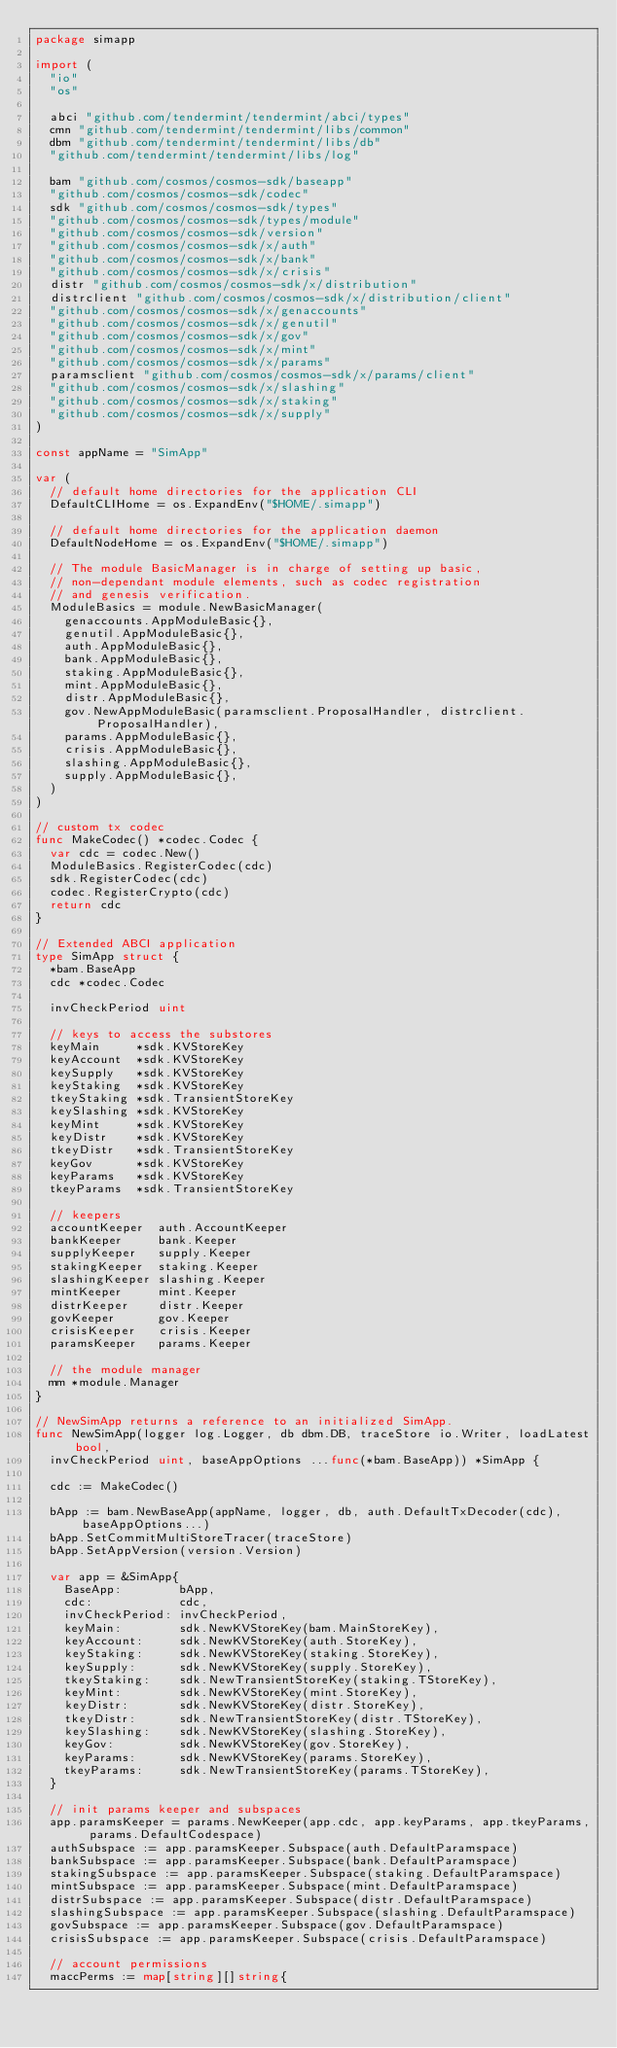<code> <loc_0><loc_0><loc_500><loc_500><_Go_>package simapp

import (
	"io"
	"os"

	abci "github.com/tendermint/tendermint/abci/types"
	cmn "github.com/tendermint/tendermint/libs/common"
	dbm "github.com/tendermint/tendermint/libs/db"
	"github.com/tendermint/tendermint/libs/log"

	bam "github.com/cosmos/cosmos-sdk/baseapp"
	"github.com/cosmos/cosmos-sdk/codec"
	sdk "github.com/cosmos/cosmos-sdk/types"
	"github.com/cosmos/cosmos-sdk/types/module"
	"github.com/cosmos/cosmos-sdk/version"
	"github.com/cosmos/cosmos-sdk/x/auth"
	"github.com/cosmos/cosmos-sdk/x/bank"
	"github.com/cosmos/cosmos-sdk/x/crisis"
	distr "github.com/cosmos/cosmos-sdk/x/distribution"
	distrclient "github.com/cosmos/cosmos-sdk/x/distribution/client"
	"github.com/cosmos/cosmos-sdk/x/genaccounts"
	"github.com/cosmos/cosmos-sdk/x/genutil"
	"github.com/cosmos/cosmos-sdk/x/gov"
	"github.com/cosmos/cosmos-sdk/x/mint"
	"github.com/cosmos/cosmos-sdk/x/params"
	paramsclient "github.com/cosmos/cosmos-sdk/x/params/client"
	"github.com/cosmos/cosmos-sdk/x/slashing"
	"github.com/cosmos/cosmos-sdk/x/staking"
	"github.com/cosmos/cosmos-sdk/x/supply"
)

const appName = "SimApp"

var (
	// default home directories for the application CLI
	DefaultCLIHome = os.ExpandEnv("$HOME/.simapp")

	// default home directories for the application daemon
	DefaultNodeHome = os.ExpandEnv("$HOME/.simapp")

	// The module BasicManager is in charge of setting up basic,
	// non-dependant module elements, such as codec registration
	// and genesis verification.
	ModuleBasics = module.NewBasicManager(
		genaccounts.AppModuleBasic{},
		genutil.AppModuleBasic{},
		auth.AppModuleBasic{},
		bank.AppModuleBasic{},
		staking.AppModuleBasic{},
		mint.AppModuleBasic{},
		distr.AppModuleBasic{},
		gov.NewAppModuleBasic(paramsclient.ProposalHandler, distrclient.ProposalHandler),
		params.AppModuleBasic{},
		crisis.AppModuleBasic{},
		slashing.AppModuleBasic{},
		supply.AppModuleBasic{},
	)
)

// custom tx codec
func MakeCodec() *codec.Codec {
	var cdc = codec.New()
	ModuleBasics.RegisterCodec(cdc)
	sdk.RegisterCodec(cdc)
	codec.RegisterCrypto(cdc)
	return cdc
}

// Extended ABCI application
type SimApp struct {
	*bam.BaseApp
	cdc *codec.Codec

	invCheckPeriod uint

	// keys to access the substores
	keyMain     *sdk.KVStoreKey
	keyAccount  *sdk.KVStoreKey
	keySupply   *sdk.KVStoreKey
	keyStaking  *sdk.KVStoreKey
	tkeyStaking *sdk.TransientStoreKey
	keySlashing *sdk.KVStoreKey
	keyMint     *sdk.KVStoreKey
	keyDistr    *sdk.KVStoreKey
	tkeyDistr   *sdk.TransientStoreKey
	keyGov      *sdk.KVStoreKey
	keyParams   *sdk.KVStoreKey
	tkeyParams  *sdk.TransientStoreKey

	// keepers
	accountKeeper  auth.AccountKeeper
	bankKeeper     bank.Keeper
	supplyKeeper   supply.Keeper
	stakingKeeper  staking.Keeper
	slashingKeeper slashing.Keeper
	mintKeeper     mint.Keeper
	distrKeeper    distr.Keeper
	govKeeper      gov.Keeper
	crisisKeeper   crisis.Keeper
	paramsKeeper   params.Keeper

	// the module manager
	mm *module.Manager
}

// NewSimApp returns a reference to an initialized SimApp.
func NewSimApp(logger log.Logger, db dbm.DB, traceStore io.Writer, loadLatest bool,
	invCheckPeriod uint, baseAppOptions ...func(*bam.BaseApp)) *SimApp {

	cdc := MakeCodec()

	bApp := bam.NewBaseApp(appName, logger, db, auth.DefaultTxDecoder(cdc), baseAppOptions...)
	bApp.SetCommitMultiStoreTracer(traceStore)
	bApp.SetAppVersion(version.Version)

	var app = &SimApp{
		BaseApp:        bApp,
		cdc:            cdc,
		invCheckPeriod: invCheckPeriod,
		keyMain:        sdk.NewKVStoreKey(bam.MainStoreKey),
		keyAccount:     sdk.NewKVStoreKey(auth.StoreKey),
		keyStaking:     sdk.NewKVStoreKey(staking.StoreKey),
		keySupply:      sdk.NewKVStoreKey(supply.StoreKey),
		tkeyStaking:    sdk.NewTransientStoreKey(staking.TStoreKey),
		keyMint:        sdk.NewKVStoreKey(mint.StoreKey),
		keyDistr:       sdk.NewKVStoreKey(distr.StoreKey),
		tkeyDistr:      sdk.NewTransientStoreKey(distr.TStoreKey),
		keySlashing:    sdk.NewKVStoreKey(slashing.StoreKey),
		keyGov:         sdk.NewKVStoreKey(gov.StoreKey),
		keyParams:      sdk.NewKVStoreKey(params.StoreKey),
		tkeyParams:     sdk.NewTransientStoreKey(params.TStoreKey),
	}

	// init params keeper and subspaces
	app.paramsKeeper = params.NewKeeper(app.cdc, app.keyParams, app.tkeyParams, params.DefaultCodespace)
	authSubspace := app.paramsKeeper.Subspace(auth.DefaultParamspace)
	bankSubspace := app.paramsKeeper.Subspace(bank.DefaultParamspace)
	stakingSubspace := app.paramsKeeper.Subspace(staking.DefaultParamspace)
	mintSubspace := app.paramsKeeper.Subspace(mint.DefaultParamspace)
	distrSubspace := app.paramsKeeper.Subspace(distr.DefaultParamspace)
	slashingSubspace := app.paramsKeeper.Subspace(slashing.DefaultParamspace)
	govSubspace := app.paramsKeeper.Subspace(gov.DefaultParamspace)
	crisisSubspace := app.paramsKeeper.Subspace(crisis.DefaultParamspace)

	// account permissions
	maccPerms := map[string][]string{</code> 